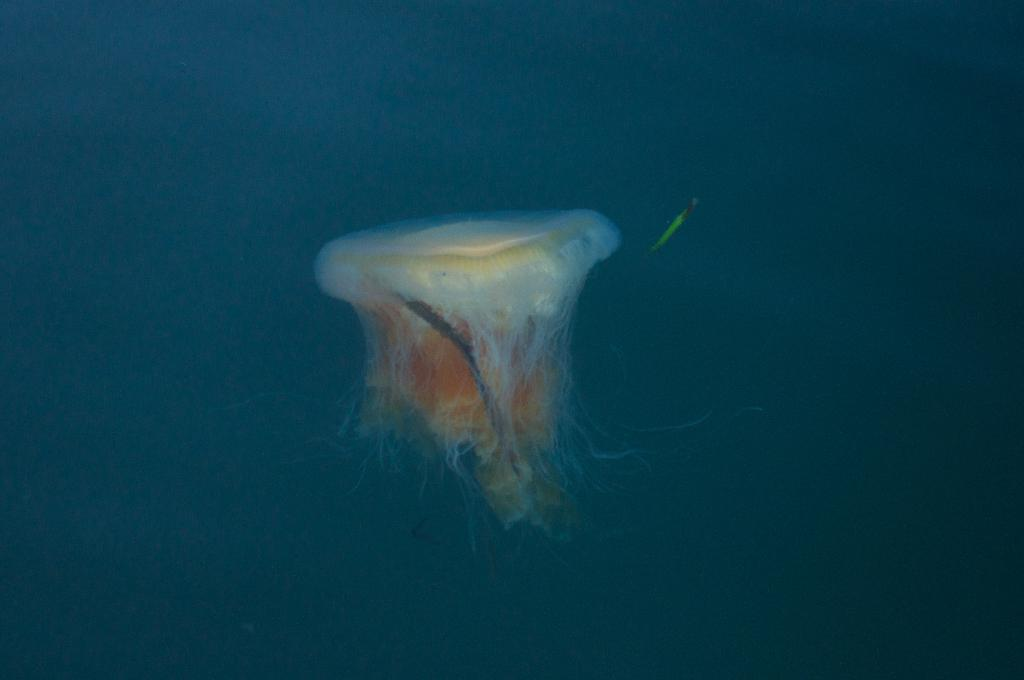What type of sea creature is in the water in the image? There is a jellyfish in the water in the image. What else can be seen in the water beside the jellyfish? There is an object beside the jellyfish. What is the title of the prose piece that describes the jellyfish in the image? There is no prose piece or title mentioned in the image or the provided facts. 